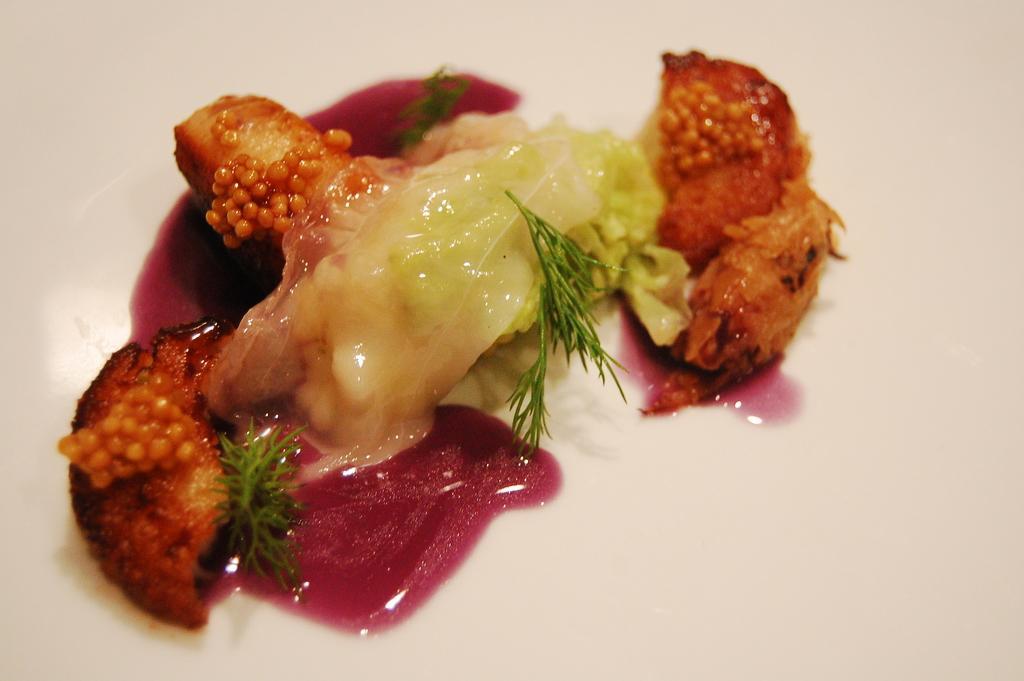How would you summarize this image in a sentence or two? In this picture we can see food on the surface. 